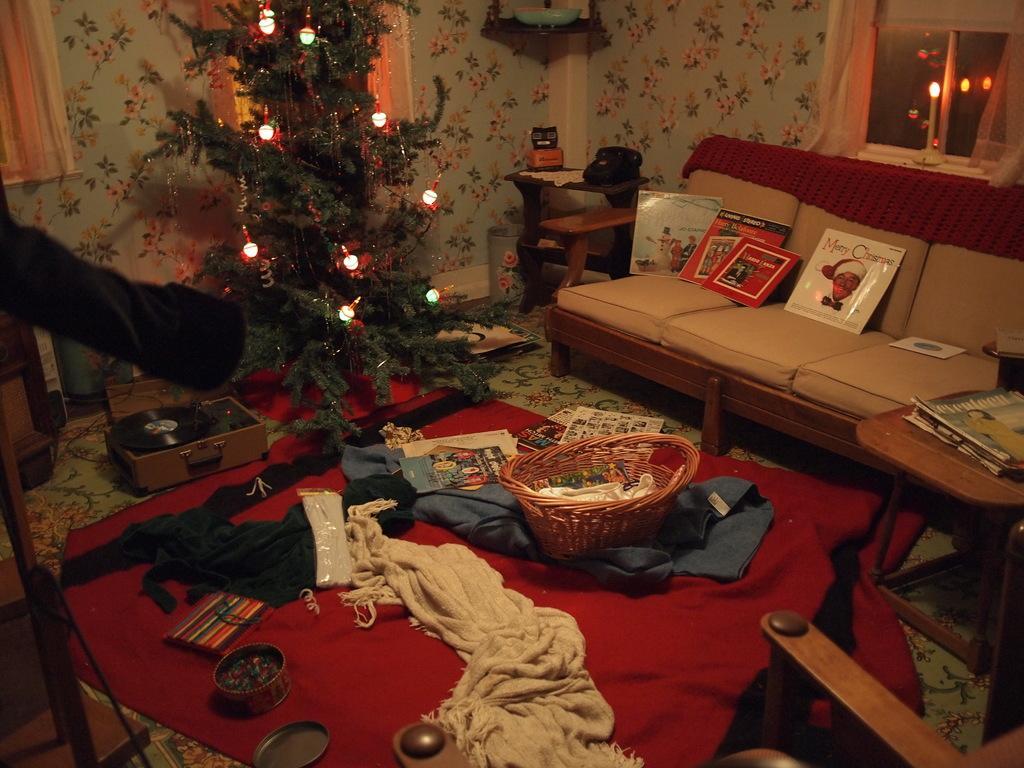Can you describe this image briefly? In this picture we can see a room with sofa pillows and books on it aside to this table cloth, basket with toys, box, Christmas tree and in background we can see wall, windows, curtains. 